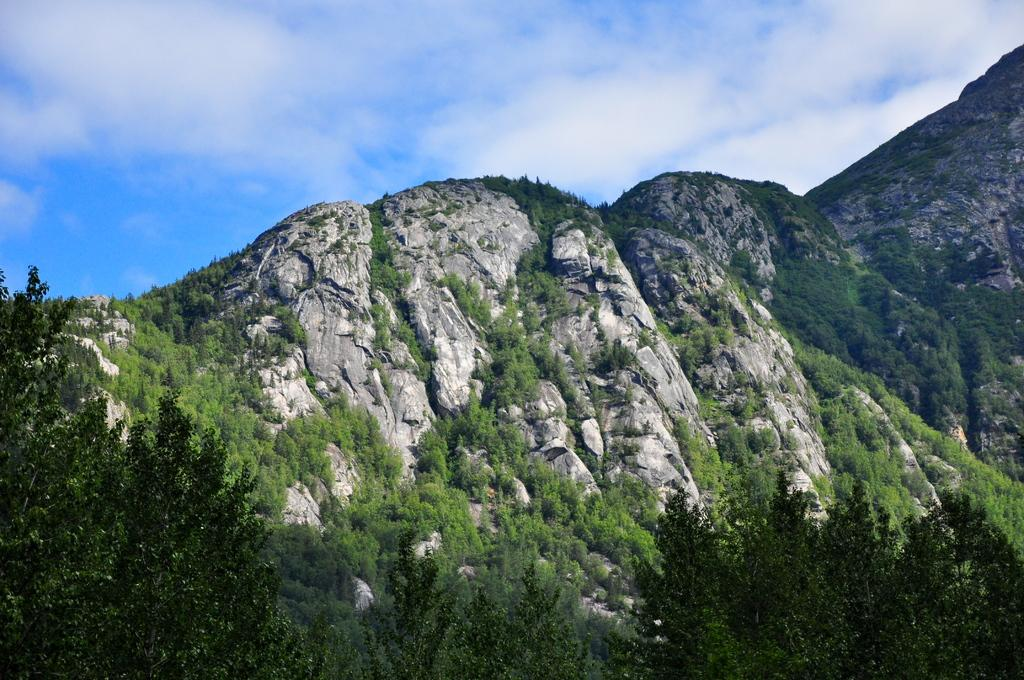What type of natural formation can be seen in the image? There are mountains in the image. What type of vegetation is present in the image? There are green color plants and trees in the image. What part of the natural environment is visible in the image? The sky is visible in the image. What is the color of the sky in the image? The sky is blue in color. What else can be seen in the sky in the image? There are clouds in the sky, which are white in color. Can you find the receipt for the purchase of the mountains in the image? There is no receipt present in the image, as mountains are natural formations and not purchasable items. How many houses can be seen in the image? There are no houses visible in the image; it features mountains, plants, trees, and a sky with clouds. 